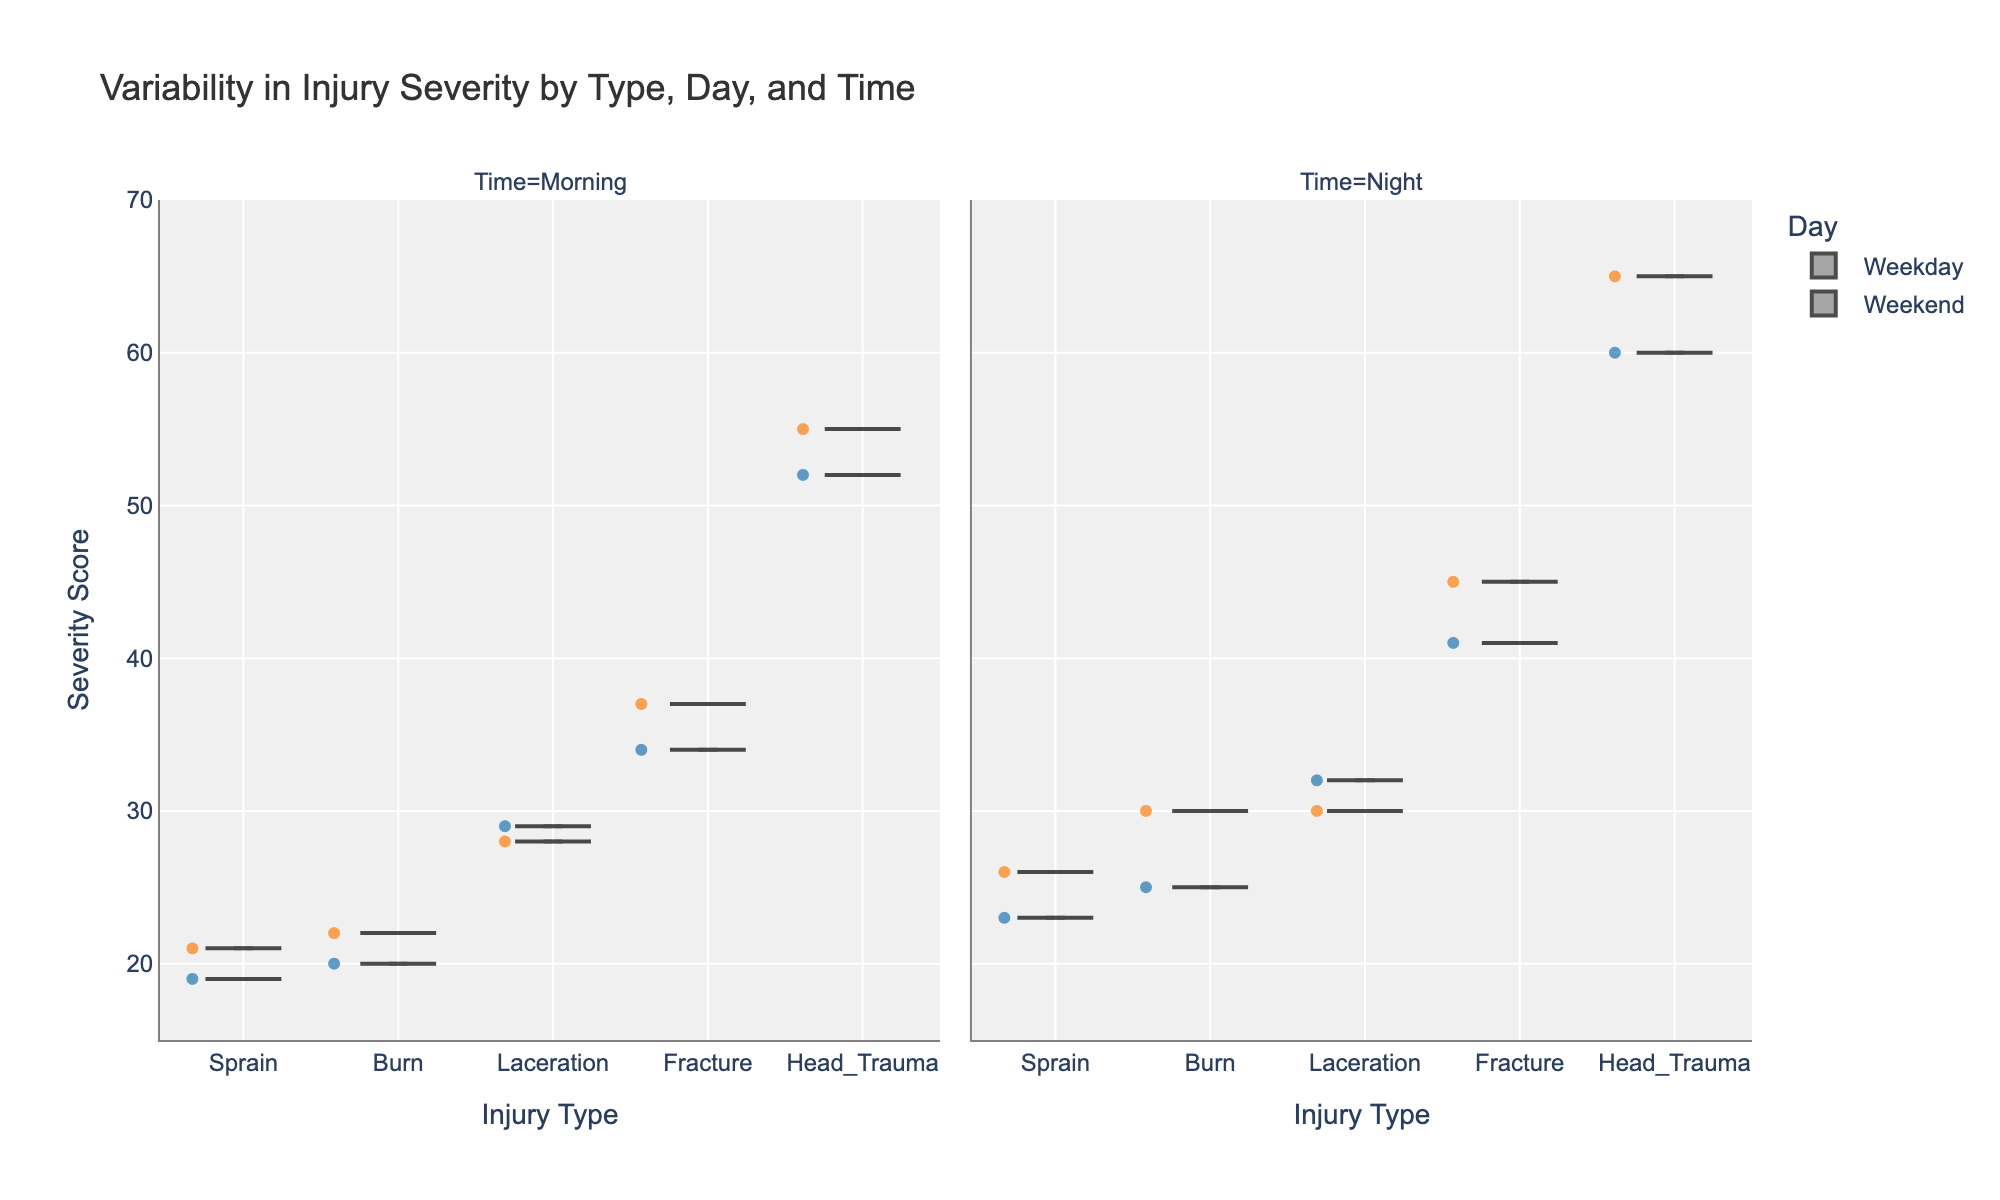what is the title of the chart? The title is usually placed at the top of the chart and describes what the chart is depicting. In this case, it is clearly written and centered above the plot.
Answer: Variability in Injury Severity by Type, Day, and Time what colors are used to differentiate between weekdays and weekends? By examining the legend or looking at the colors used in the violin plots, we can see which colors correspond to weekdays and weekends. Weekdays are represented in blue, and weekends are represented in orange.
Answer: Blue and Orange which injury type has the highest median severity score during nights on weekends? Looking at the box plot overlay on the violin chart, we identify the median line within the violins for each injury type during nighttime on weekends. Head Trauma has the highest median, visually higher than other injury types.
Answer: Head Trauma on weekday mornings, which injury type shows the greatest variability in severity scores? Variability in severity scores can be assessed by observing the width and spread of the violin plots. The broader and more spread out the violin, the greater the variability. Head Trauma shows the broadest spread among injury types on weekday mornings.
Answer: Head Trauma how does the severity score of fractures vary between weekday nights and weekend nights? By comparing the two violin plots for Fracture under "Night" for weekdays and weekends, we can assess visible differences. Severity scores for fractures appear slightly higher on weekend nights compared to weekday nights.
Answer: Higher on weekend nights what is the lowest severity score observed for burns, and when does it occur? By looking at the ends of the violins for Burns and identifying the minimum value points across all categories, the lowest severity score for Burns is observed to be 20, which occurs on weekday mornings.
Answer: 20 on weekday mornings which injury type consistently shows the lowest severity scores across all times and days? Observing all the violins and box plots, we note the position of the central tendency lines and overall values. Sprains demonstrate the lowest severity scores consistently in all categories.
Answer: Sprain compare the median severity score of head trauma to the median severity score of lacerations on weekday nights. Locate the median lines within the violin plots for both Head Trauma and Lacerations on weekday nights and compare them directly. Head Trauma has visibly higher median scores compared to Lacerations.
Answer: Head Trauma is higher what is the range of severity scores for fractures during weekday mornings? The range is determined by the minimum and maximum values within the violin plot, supplemented by the box plot. For weekday mornings, fractures have a range from about 34 to 45.
Answer: 34 to 45 for which injury type and time is there the least difference in severity scores between weekdays and weekends? By examining the overlap and spread of the violin plots for the same injury type under both weekday and weekend conditions, Lacerations during the morning times show minimal differences in severity scores.
Answer: Lacerations during morning 